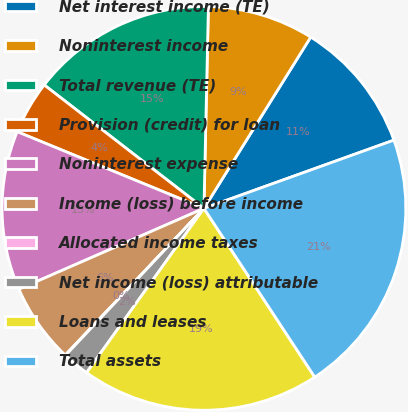<chart> <loc_0><loc_0><loc_500><loc_500><pie_chart><fcel>Net interest income (TE)<fcel>Noninterest income<fcel>Total revenue (TE)<fcel>Provision (credit) for loan<fcel>Noninterest expense<fcel>Income (loss) before income<fcel>Allocated income taxes<fcel>Net income (loss) attributable<fcel>Loans and leases<fcel>Total assets<nl><fcel>10.64%<fcel>8.52%<fcel>14.88%<fcel>4.27%<fcel>12.76%<fcel>6.39%<fcel>0.03%<fcel>2.15%<fcel>19.12%<fcel>21.24%<nl></chart> 